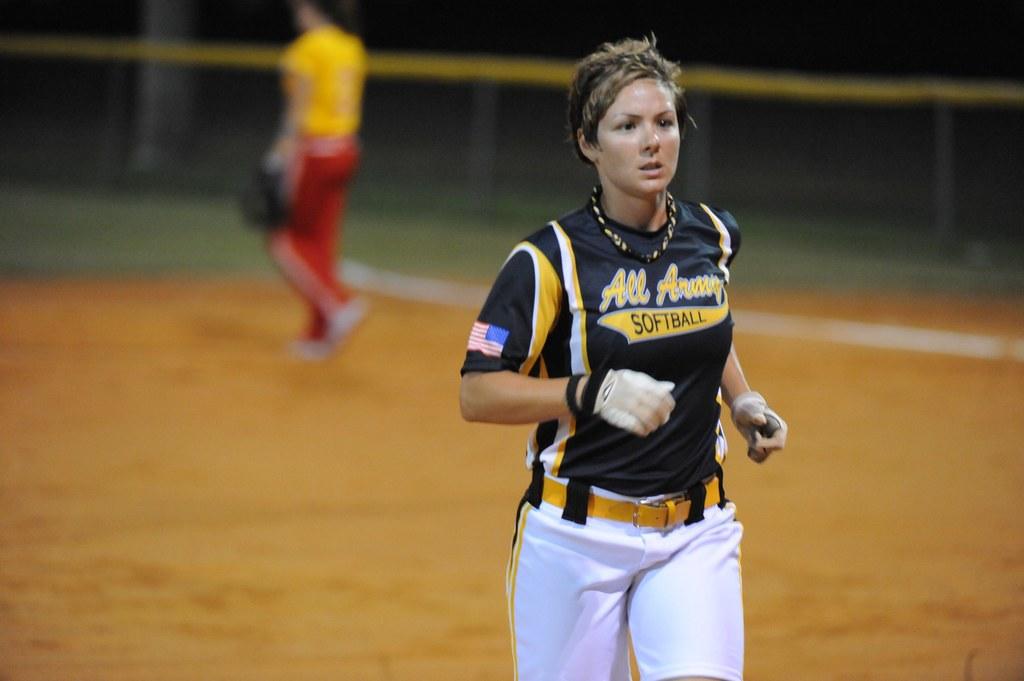Is the word "all" on the jersey?
Your response must be concise. Yes. 